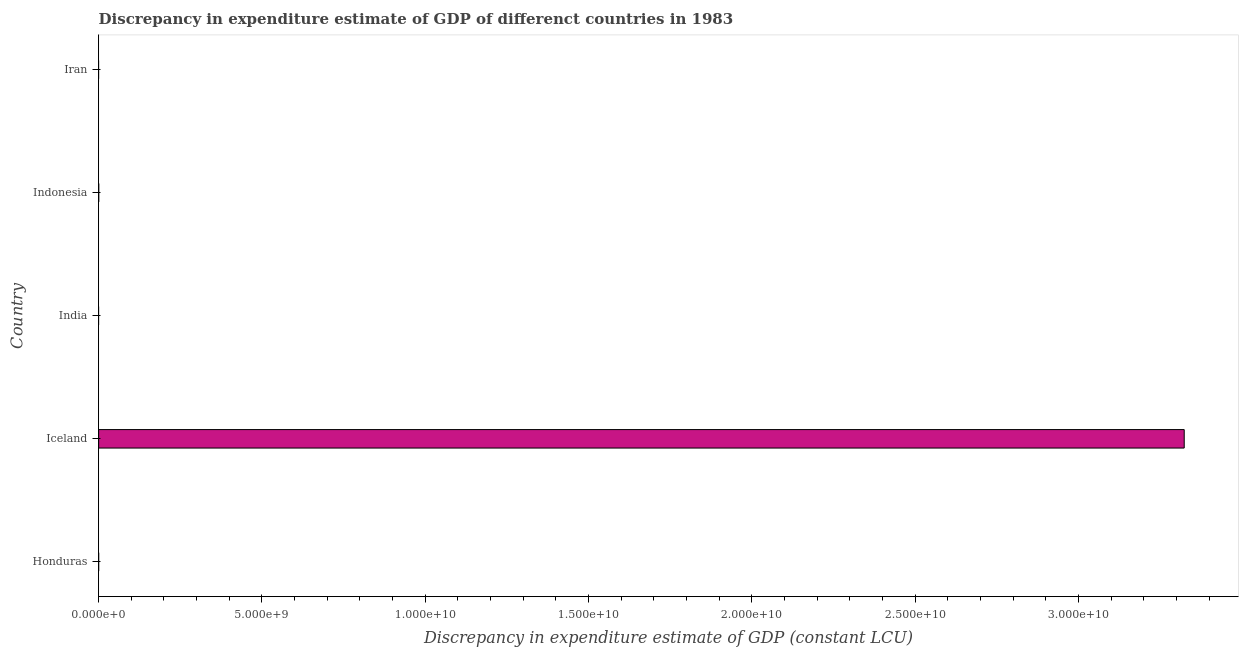What is the title of the graph?
Keep it short and to the point. Discrepancy in expenditure estimate of GDP of differenct countries in 1983. What is the label or title of the X-axis?
Offer a very short reply. Discrepancy in expenditure estimate of GDP (constant LCU). What is the discrepancy in expenditure estimate of gdp in India?
Your answer should be very brief. 0. Across all countries, what is the maximum discrepancy in expenditure estimate of gdp?
Your response must be concise. 3.32e+1. Across all countries, what is the minimum discrepancy in expenditure estimate of gdp?
Offer a terse response. 0. In which country was the discrepancy in expenditure estimate of gdp maximum?
Provide a succinct answer. Iceland. What is the sum of the discrepancy in expenditure estimate of gdp?
Your answer should be very brief. 3.32e+1. What is the difference between the discrepancy in expenditure estimate of gdp in Honduras and Iceland?
Give a very brief answer. -3.32e+1. What is the average discrepancy in expenditure estimate of gdp per country?
Provide a succinct answer. 6.65e+09. What is the median discrepancy in expenditure estimate of gdp?
Provide a short and direct response. 5.89e+04. What is the ratio of the discrepancy in expenditure estimate of gdp in Iceland to that in Indonesia?
Make the answer very short. 1.08e+04. What is the difference between the highest and the second highest discrepancy in expenditure estimate of gdp?
Offer a terse response. 3.32e+1. Is the sum of the discrepancy in expenditure estimate of gdp in Honduras and Iceland greater than the maximum discrepancy in expenditure estimate of gdp across all countries?
Your answer should be very brief. Yes. What is the difference between the highest and the lowest discrepancy in expenditure estimate of gdp?
Offer a very short reply. 3.32e+1. Are all the bars in the graph horizontal?
Offer a terse response. Yes. What is the Discrepancy in expenditure estimate of GDP (constant LCU) in Honduras?
Provide a short and direct response. 5.89e+04. What is the Discrepancy in expenditure estimate of GDP (constant LCU) in Iceland?
Your answer should be very brief. 3.32e+1. What is the Discrepancy in expenditure estimate of GDP (constant LCU) of India?
Make the answer very short. 0. What is the Discrepancy in expenditure estimate of GDP (constant LCU) of Indonesia?
Offer a very short reply. 3.06e+06. What is the difference between the Discrepancy in expenditure estimate of GDP (constant LCU) in Honduras and Iceland?
Your answer should be compact. -3.32e+1. What is the difference between the Discrepancy in expenditure estimate of GDP (constant LCU) in Honduras and Indonesia?
Offer a terse response. -3.01e+06. What is the difference between the Discrepancy in expenditure estimate of GDP (constant LCU) in Iceland and Indonesia?
Make the answer very short. 3.32e+1. What is the ratio of the Discrepancy in expenditure estimate of GDP (constant LCU) in Honduras to that in Indonesia?
Your response must be concise. 0.02. What is the ratio of the Discrepancy in expenditure estimate of GDP (constant LCU) in Iceland to that in Indonesia?
Offer a very short reply. 1.08e+04. 